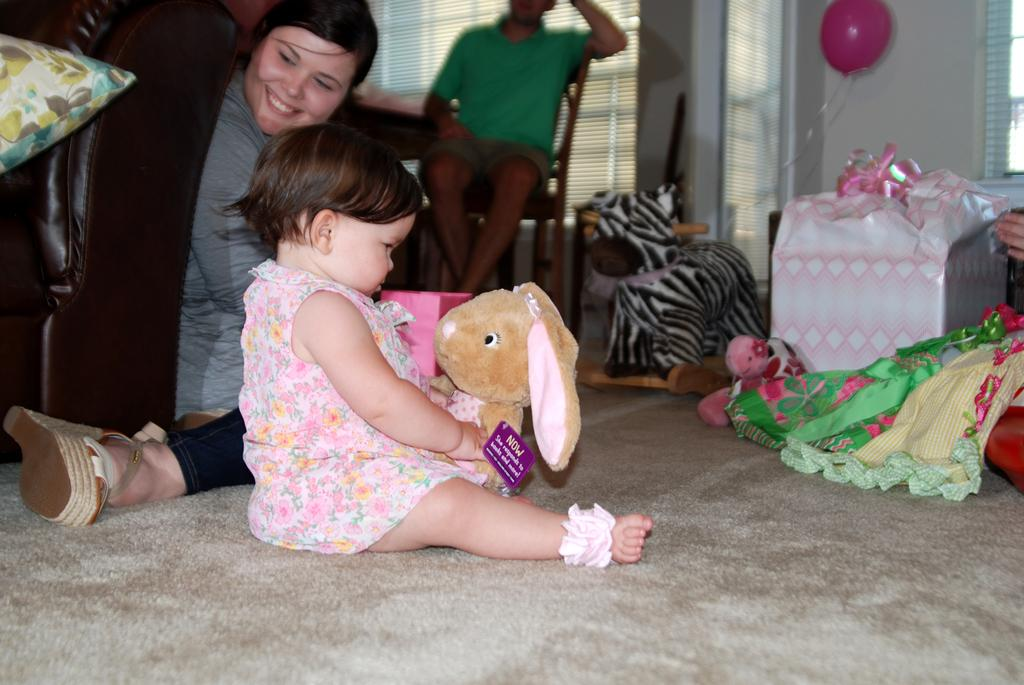What is the main subject of the image? The main subject of the image is a group of persons. Can you describe the kid in the image? The kid is playing with dolls in the image. What other objects can be seen in the image? There is a balloon and a gift in the image. What type of music is being played by the thumb in the image? There is no thumb or music present in the image. How many fingers are visible in the image? The provided facts do not mention any fingers or hands, so it cannot be determined from the image. 